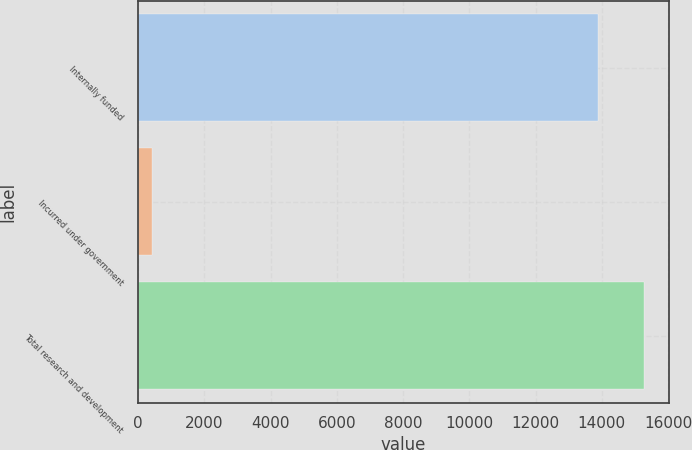Convert chart to OTSL. <chart><loc_0><loc_0><loc_500><loc_500><bar_chart><fcel>Internally funded<fcel>Incurred under government<fcel>Total research and development<nl><fcel>13877<fcel>422<fcel>15264.7<nl></chart> 